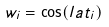Convert formula to latex. <formula><loc_0><loc_0><loc_500><loc_500>w _ { i } = \cos ( l a t _ { i } )</formula> 